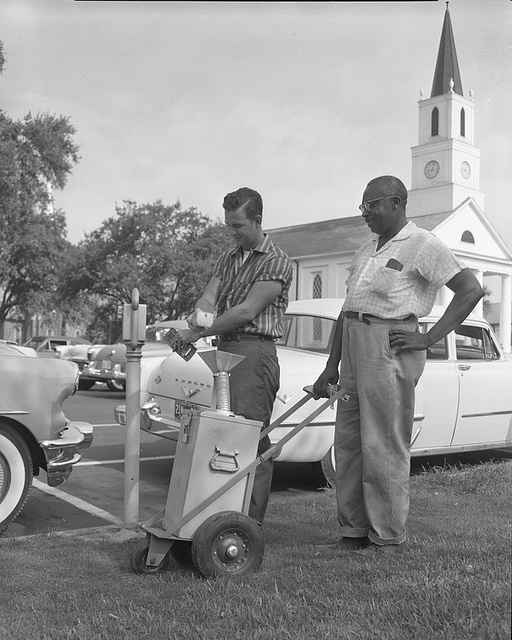Describe the objects in this image and their specific colors. I can see people in darkgray, gray, lightgray, and black tones, car in darkgray, lightgray, gray, and black tones, people in darkgray, gray, black, and lightgray tones, car in darkgray, gray, lightgray, and black tones, and car in darkgray, gray, lightgray, and black tones in this image. 